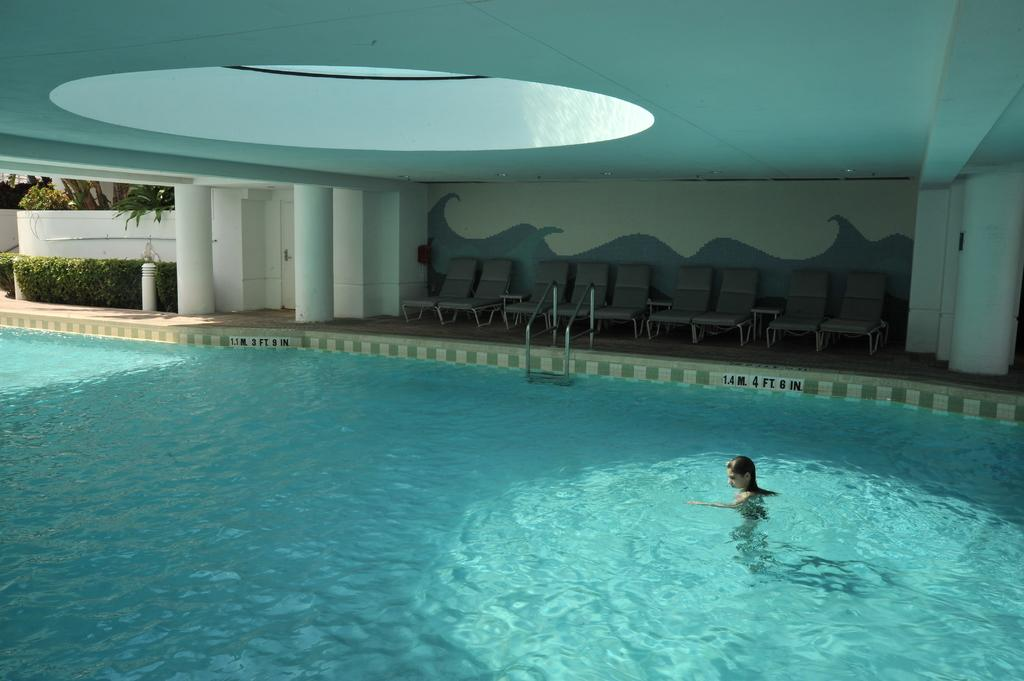What is the person in the image doing? There is a person swimming in the water. What type of furniture can be seen in the image? There are chairs in the image. What architectural features are present in the image? There are pillars in the image. What type of vegetation is visible in the image? There are shrubs in the image. What type of structure is depicted in the image? There are doors in the image. What can be seen in the background of the image? There are trees and a wall in the background of the image. Who is the creator of the team depicted in the image? There is no team depicted in the image, so it is not possible to identify a creator. 